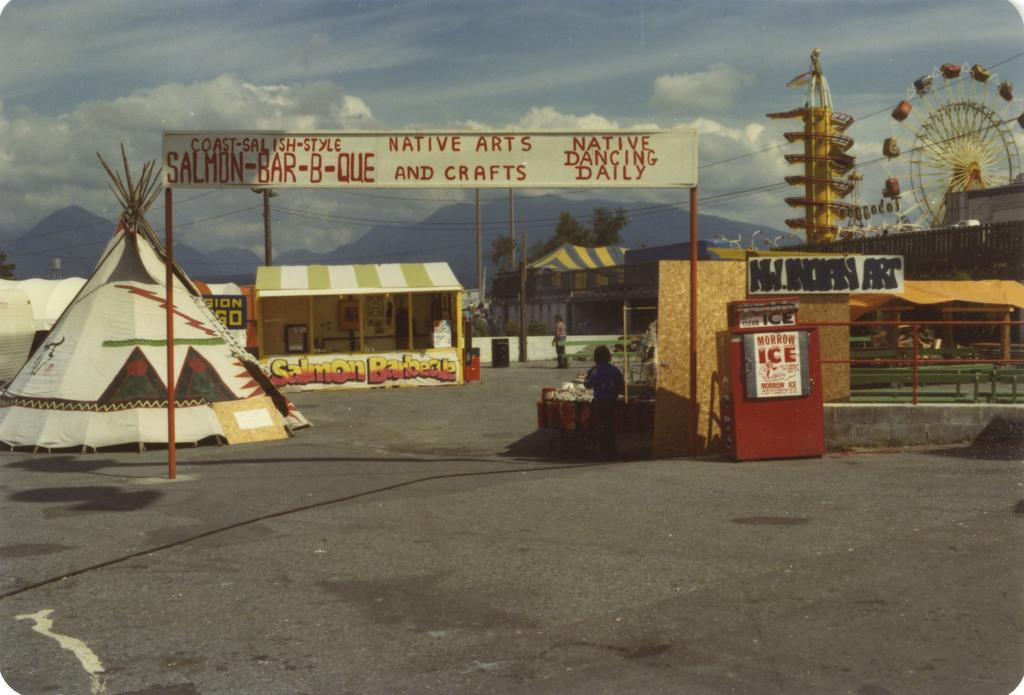What type of location is depicted in the image? The image appears to depict an exhibition park. What can be seen at the entrance of the park? There is a board at the entrance of the park. What structures can be found inside the park? Inside the park, there are tents, stalls, and amusement rides. What type of furniture can be seen in the image? There is no furniture present in the image; it depicts an exhibition park with tents, stalls, and amusement rides. What nation is hosting the exhibition in the image? The image does not provide information about the nation hosting the exhibition. 